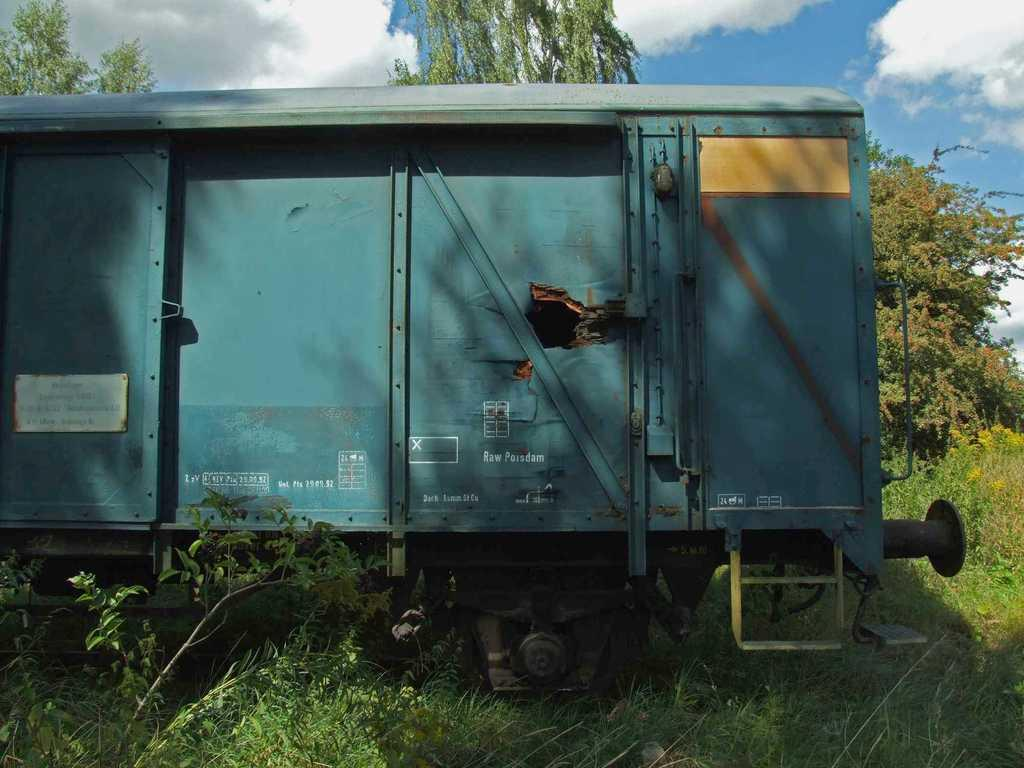What is the main subject in the center of the image? There is a train in the center of the image. What can be seen at the bottom side of the image? There are plants at the bottom side of the image. Can you tell me how many basketballs are visible in the image? There are no basketballs present in the image. What type of detail can be seen on the train in the image? The provided facts do not mention any specific details on the train, so we cannot answer this question based on the given information. 